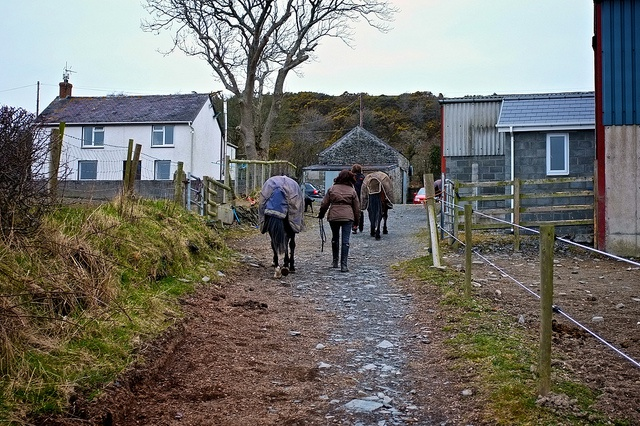Describe the objects in this image and their specific colors. I can see people in lightblue, black, gray, and darkgray tones, horse in lightblue, black, gray, and darkgray tones, horse in lightblue, black, gray, and darkgray tones, car in lightblue, gray, black, and blue tones, and people in lightblue, black, maroon, and gray tones in this image. 